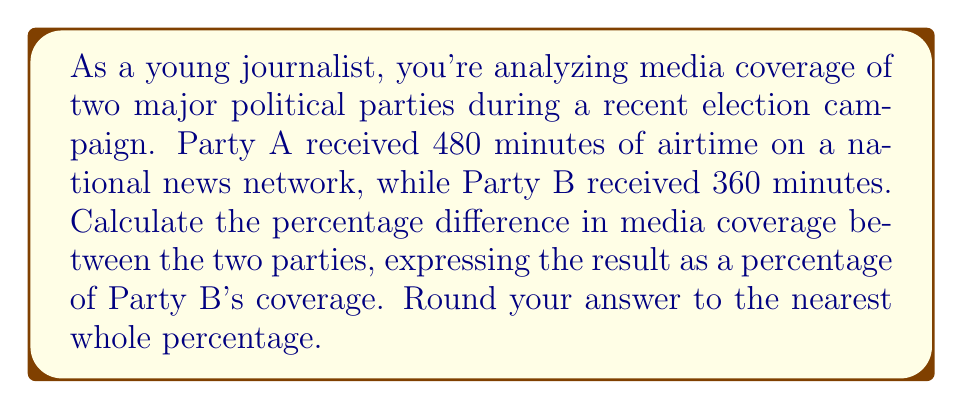Solve this math problem. To solve this problem, we'll follow these steps:

1. Calculate the difference in airtime between Party A and Party B:
   $$\text{Difference} = 480 \text{ minutes} - 360 \text{ minutes} = 120 \text{ minutes}$$

2. Express this difference as a percentage of Party B's coverage:
   $$\text{Percentage difference} = \frac{\text{Difference}}{\text{Party B's coverage}} \times 100\%$$

   $$= \frac{120 \text{ minutes}}{360 \text{ minutes}} \times 100\%$$

3. Simplify the fraction:
   $$= \frac{1}{3} \times 100\%$$

4. Perform the multiplication:
   $$= 33.33...\%$$

5. Round to the nearest whole percentage:
   $$\approx 33\%$$

This result indicates that Party A received 33% more media coverage than Party B on this particular news network.
Answer: $33\%$ 